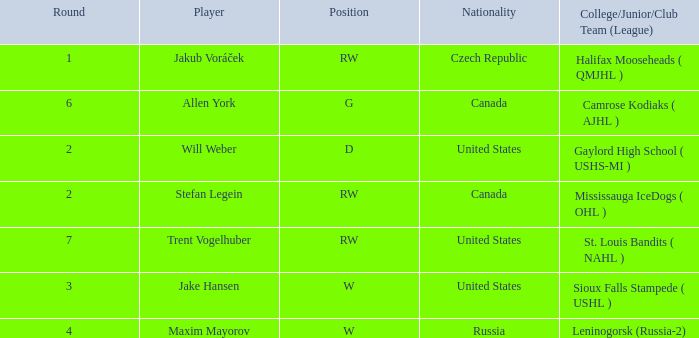What college or league did the round 2 pick with d position come from? Gaylord High School ( USHS-MI ). Would you mind parsing the complete table? {'header': ['Round', 'Player', 'Position', 'Nationality', 'College/Junior/Club Team (League)'], 'rows': [['1', 'Jakub Voráček', 'RW', 'Czech Republic', 'Halifax Mooseheads ( QMJHL )'], ['6', 'Allen York', 'G', 'Canada', 'Camrose Kodiaks ( AJHL )'], ['2', 'Will Weber', 'D', 'United States', 'Gaylord High School ( USHS-MI )'], ['2', 'Stefan Legein', 'RW', 'Canada', 'Mississauga IceDogs ( OHL )'], ['7', 'Trent Vogelhuber', 'RW', 'United States', 'St. Louis Bandits ( NAHL )'], ['3', 'Jake Hansen', 'W', 'United States', 'Sioux Falls Stampede ( USHL )'], ['4', 'Maxim Mayorov', 'W', 'Russia', 'Leninogorsk (Russia-2)']]} 